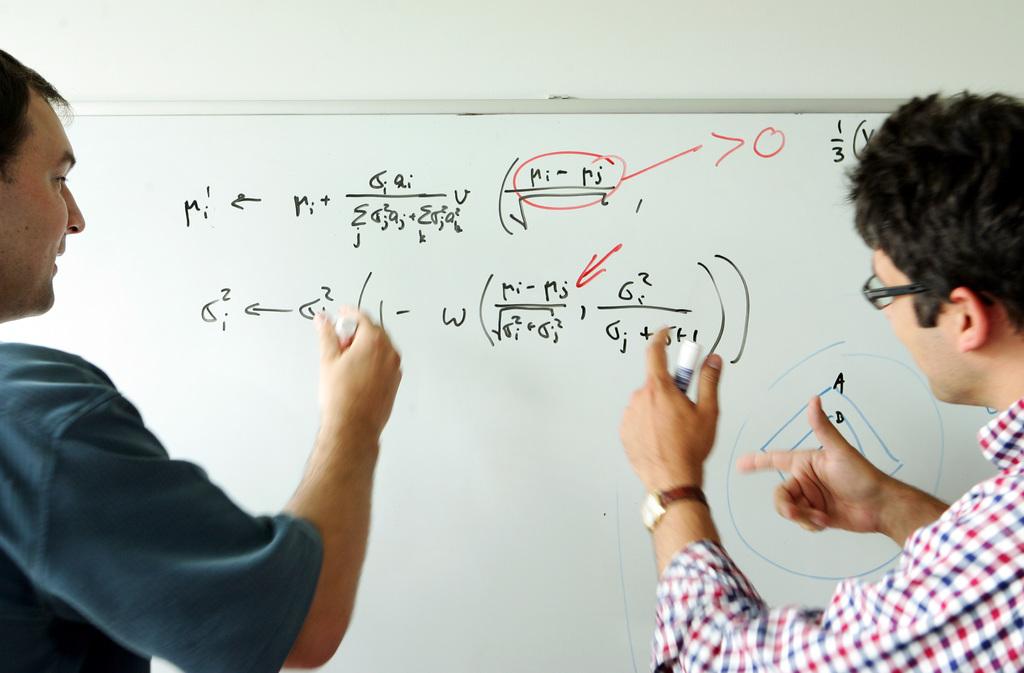What subject is being taught?
Give a very brief answer. Unanswerable. 